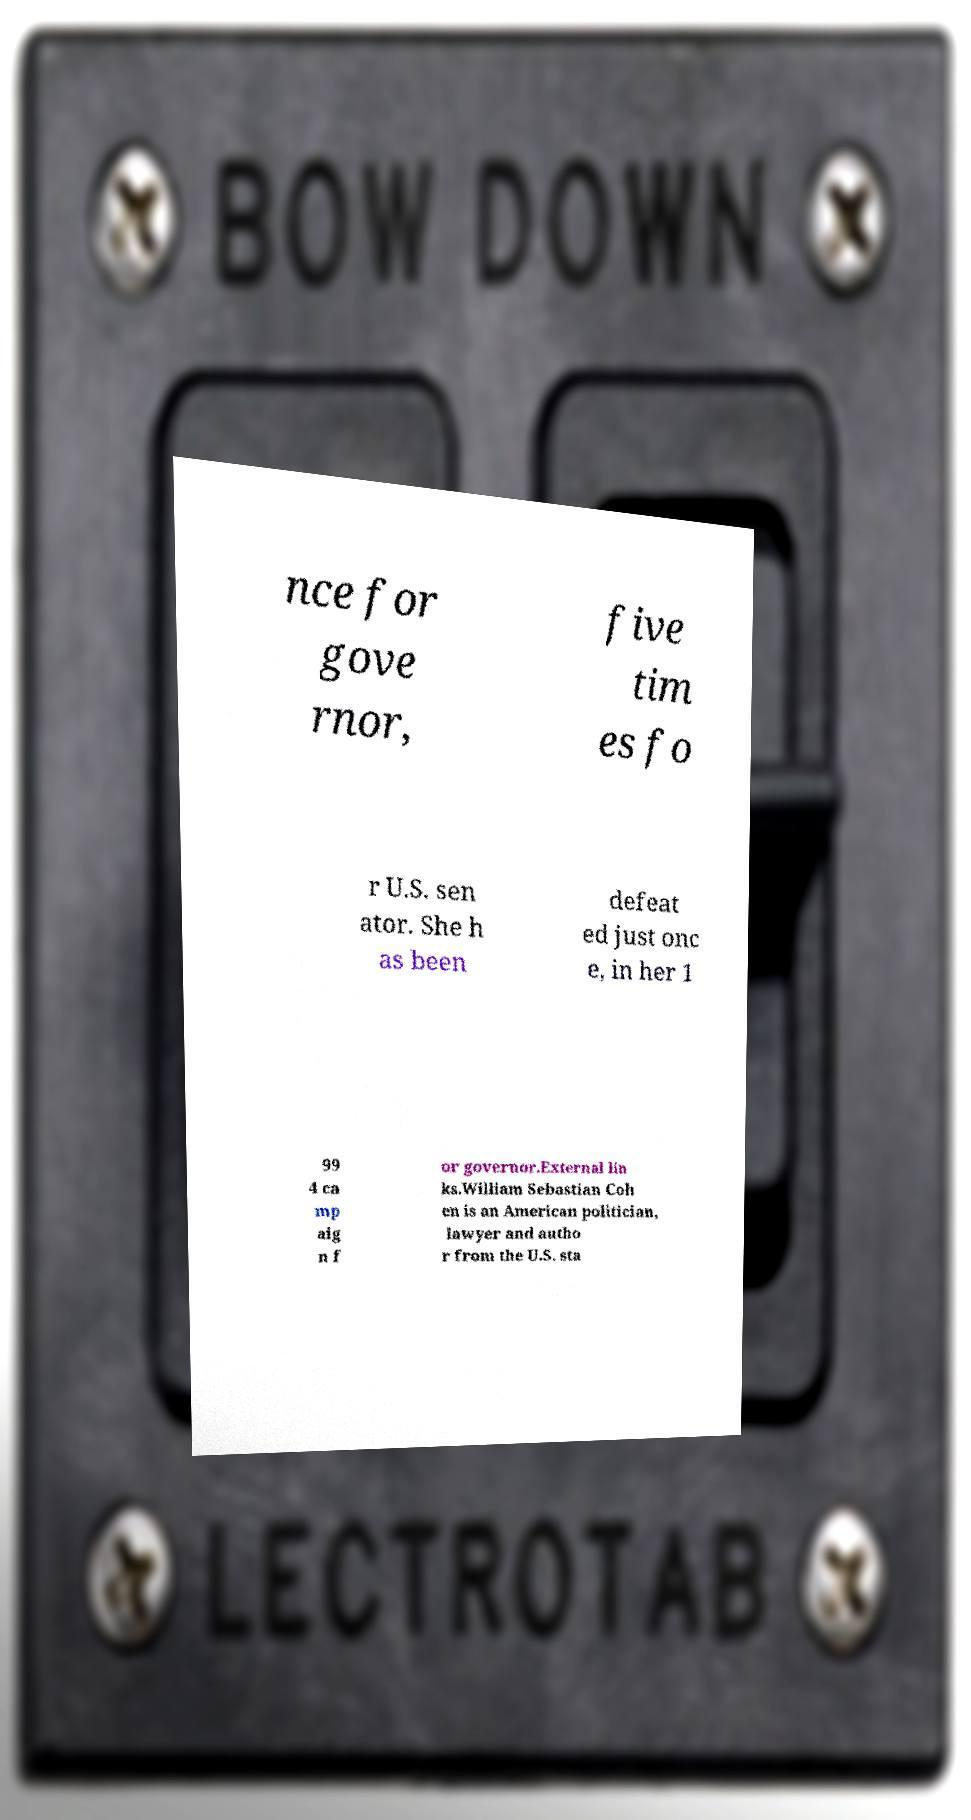Please read and relay the text visible in this image. What does it say? nce for gove rnor, five tim es fo r U.S. sen ator. She h as been defeat ed just onc e, in her 1 99 4 ca mp aig n f or governor.External lin ks.William Sebastian Coh en is an American politician, lawyer and autho r from the U.S. sta 